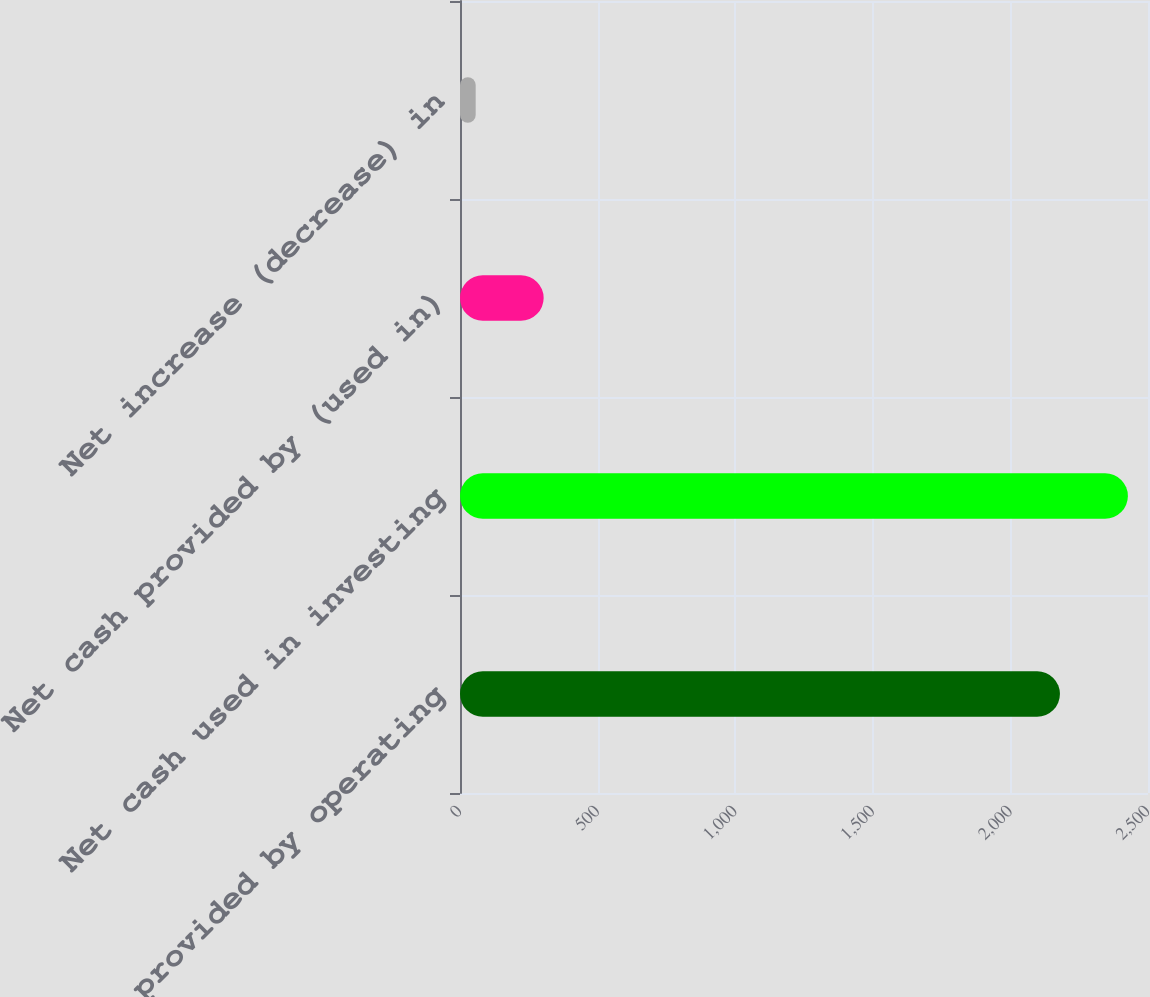Convert chart. <chart><loc_0><loc_0><loc_500><loc_500><bar_chart><fcel>Net cash provided by operating<fcel>Net cash used in investing<fcel>Net cash provided by (used in)<fcel>Net increase (decrease) in<nl><fcel>2180<fcel>2427<fcel>304<fcel>57<nl></chart> 